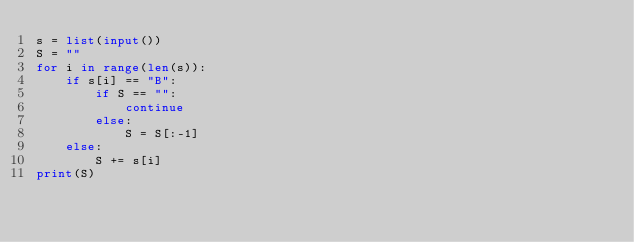Convert code to text. <code><loc_0><loc_0><loc_500><loc_500><_Python_>s = list(input())
S = ""
for i in range(len(s)):
    if s[i] == "B":
        if S == "":
            continue
        else:
            S = S[:-1]
    else:
        S += s[i]
print(S)</code> 